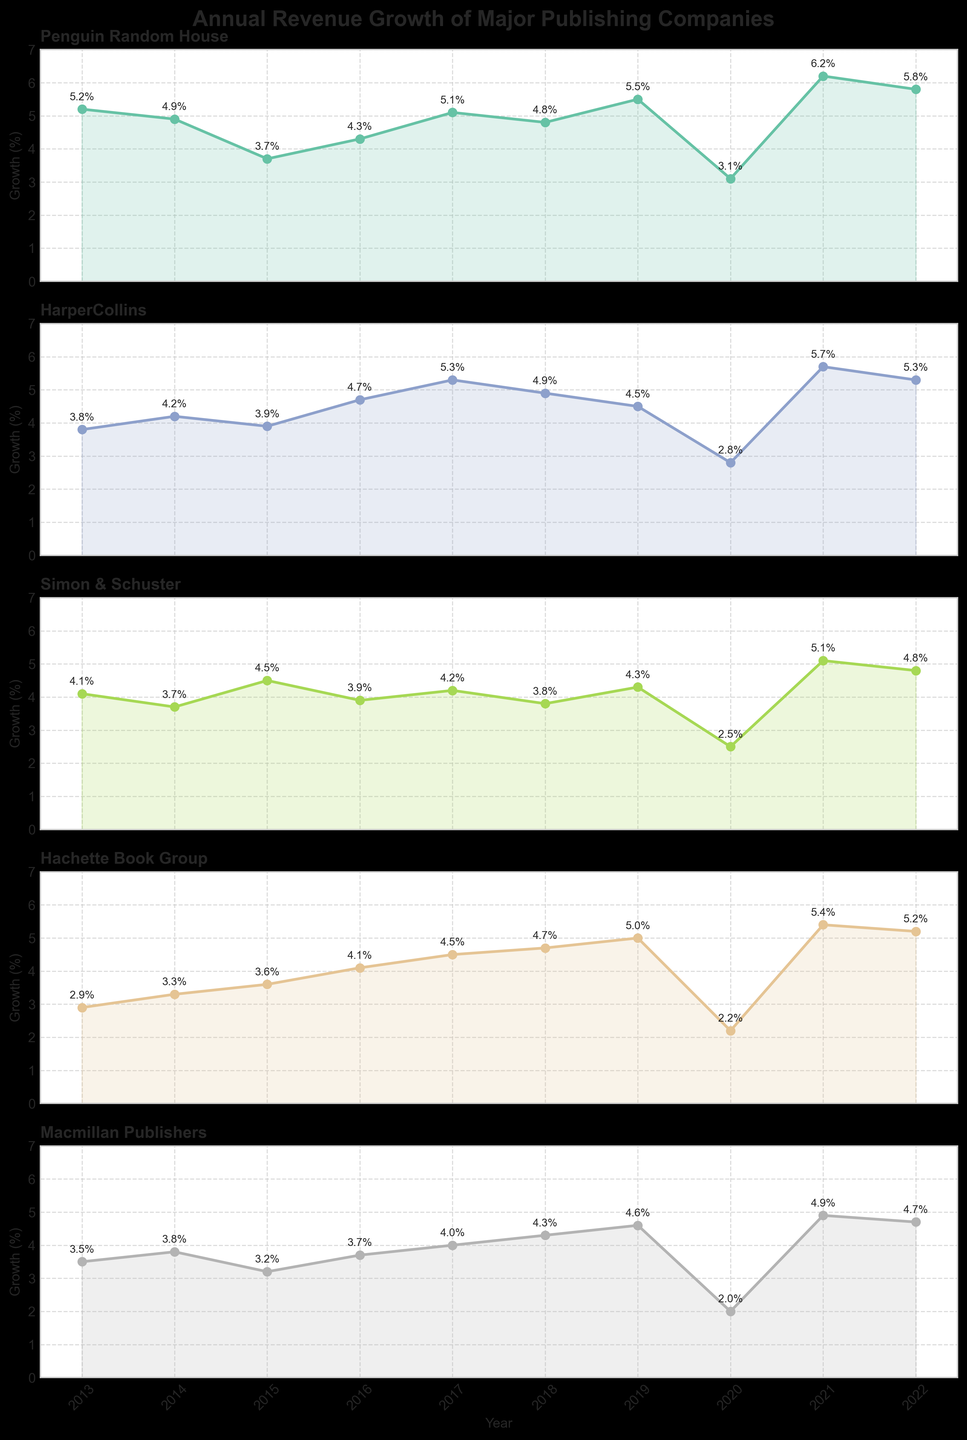What is the title of the figure? The title of the figure is usually located at the top center. By visually inspecting the figure, you can find and read the title.
Answer: Annual Revenue Growth of Major Publishing Companies Which company had the highest revenue growth in 2021? Locate the subplot for 2021 on the x-axis. Among the data points, identify the one with the highest y-value corresponding to 2021.
Answer: Penguin Random House How did HarperCollins' revenue growth change from 2013 to 2020? Look at the plot for HarperCollins and find the data points for 2013 and 2020. Subtract the growth percentage of 2020 from that of 2013.
Answer: -1.0% Which publishing company experienced the most consistent revenue growth over the decade? Identify the plots with the least fluctuations in the y-values over the span of years. Consistency is evaluated based on the smoothness and uniformity of the trend line.
Answer: Macmillan Publishers How many companies had a peak growth in 2021? Analyze each subplot to find the highest data point. Count how many companies have their highest data point in 2021.
Answer: Three companies Compare the revenue growth of Penguin Random House and Simon & Schuster in 2015. Locate the 2015 data points for both Penguin Random House and Simon & Schuster. Compare the y-values of these points.
Answer: Penguin Random House was lower What's the average growth of Hachette Book Group from 2016 to 2019? Find the data points for Hachette Book Group from 2016 to 2019. Add these growth percentages and divide by the number of years.
Answer: 4.575% Between which consecutive years did Macmillan Publishers experience the largest drop? Look at the data points for Macmillan Publishers and calculate the differences between consecutive years. Identify the largest negative difference.
Answer: 2019-2020 Which company showed a declining trend in 2020 compared to its previous year’s growth? For each subplot, compare the data point of 2020 with that of 2019. Identify the companies with a decline.
Answer: All companies Identify the years with the lowest growth for Simon & Schuster and Penguin Random House. For each subplot, find the data point with the smallest y-value.
Answer: 2020 for both companies 